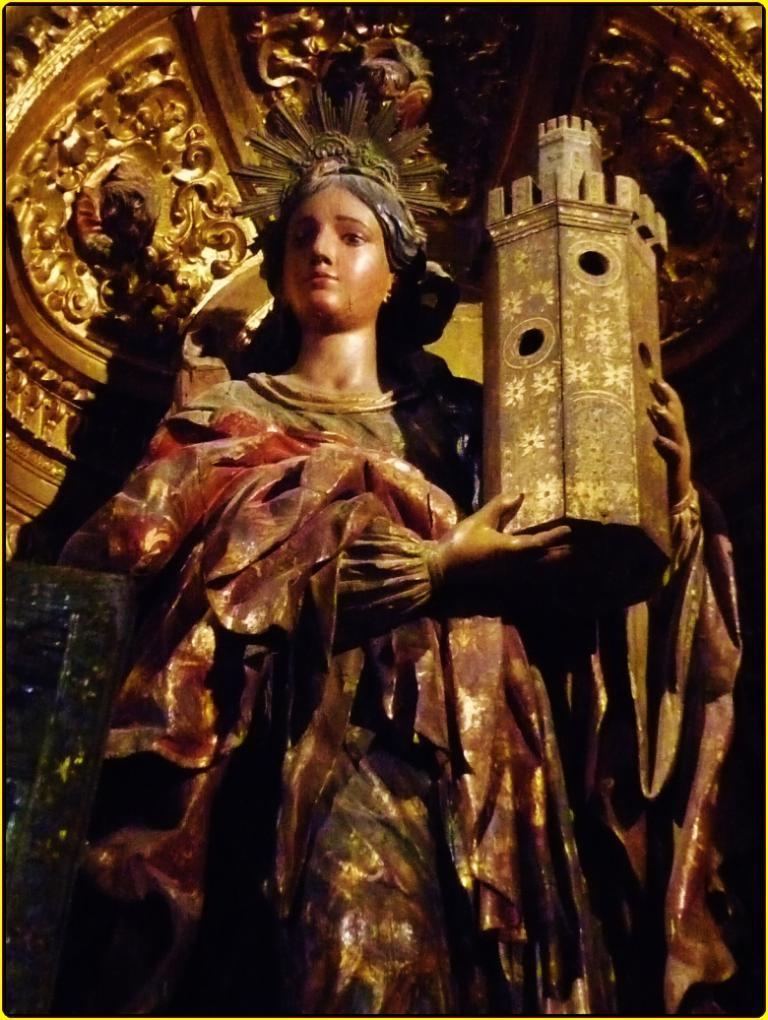In one or two sentences, can you explain what this image depicts? This image consists of a idol of a woman. She is holding a monument. 